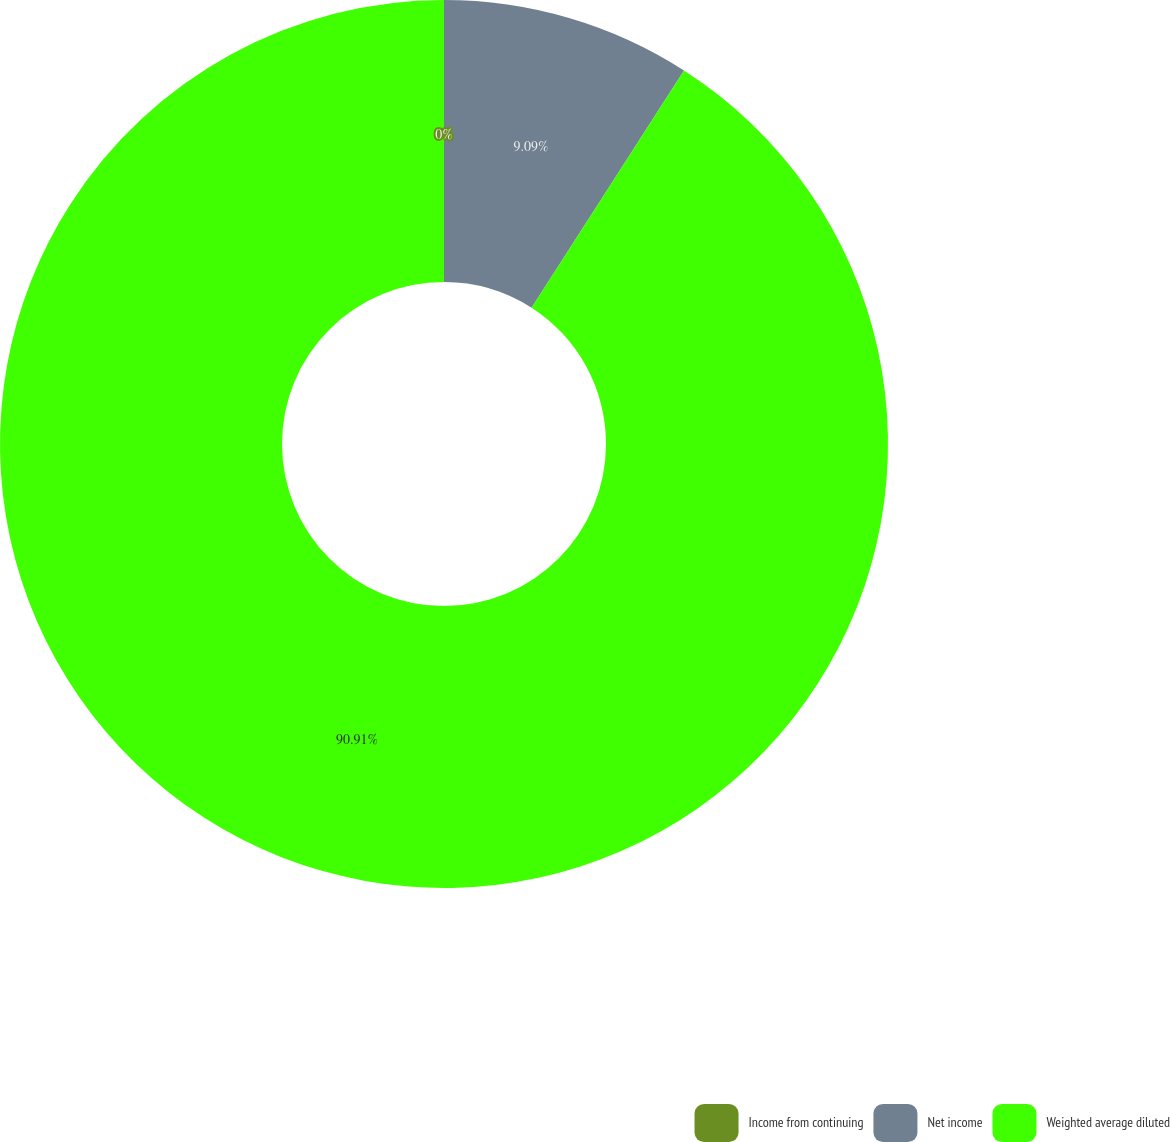<chart> <loc_0><loc_0><loc_500><loc_500><pie_chart><fcel>Income from continuing<fcel>Net income<fcel>Weighted average diluted<nl><fcel>0.0%<fcel>9.09%<fcel>90.91%<nl></chart> 